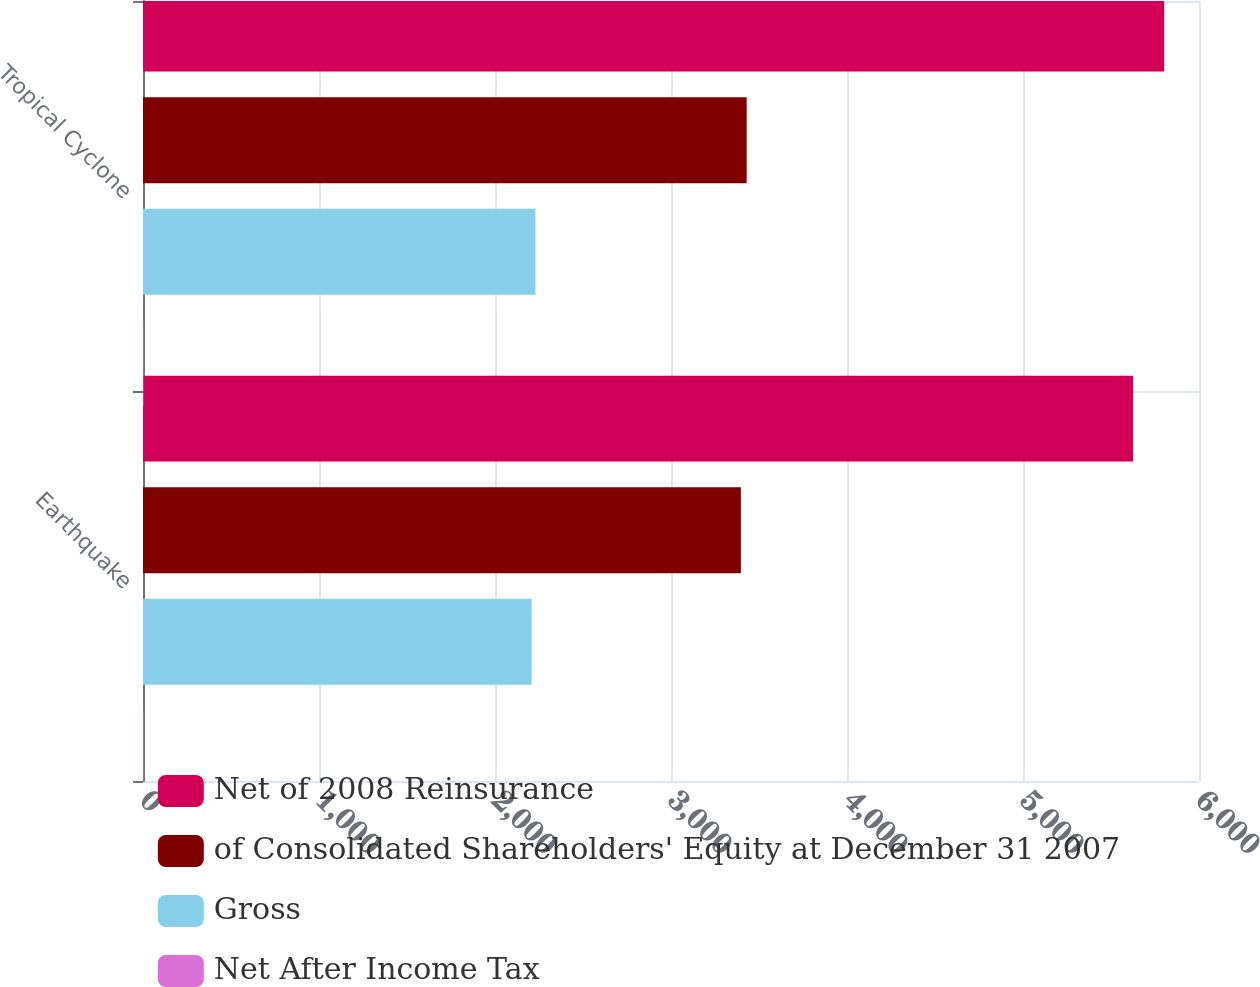<chart> <loc_0><loc_0><loc_500><loc_500><stacked_bar_chart><ecel><fcel>Earthquake<fcel>Tropical Cyclone<nl><fcel>Net of 2008 Reinsurance<fcel>5625<fcel>5802<nl><fcel>of Consolidated Shareholders' Equity at December 31 2007<fcel>3397<fcel>3430<nl><fcel>Gross<fcel>2208<fcel>2230<nl><fcel>Net After Income Tax<fcel>2.3<fcel>2.3<nl></chart> 